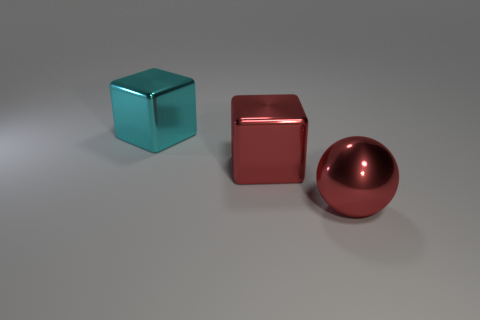Add 3 red things. How many objects exist? 6 Subtract all spheres. How many objects are left? 2 Subtract all red blocks. Subtract all big cubes. How many objects are left? 0 Add 1 cyan things. How many cyan things are left? 2 Add 2 big matte things. How many big matte things exist? 2 Subtract 1 red cubes. How many objects are left? 2 